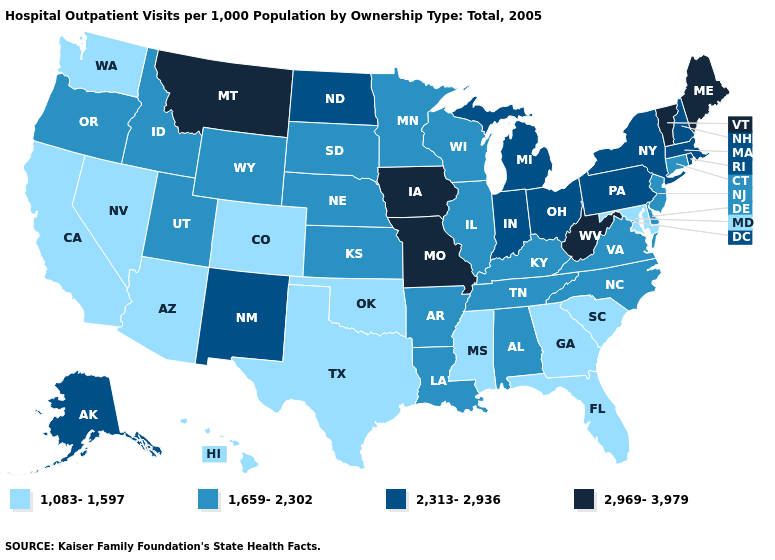What is the value of Nebraska?
Answer briefly. 1,659-2,302. Does Maine have the same value as Missouri?
Give a very brief answer. Yes. Name the states that have a value in the range 2,969-3,979?
Short answer required. Iowa, Maine, Missouri, Montana, Vermont, West Virginia. What is the value of Maine?
Short answer required. 2,969-3,979. Name the states that have a value in the range 1,083-1,597?
Short answer required. Arizona, California, Colorado, Florida, Georgia, Hawaii, Maryland, Mississippi, Nevada, Oklahoma, South Carolina, Texas, Washington. What is the value of New Jersey?
Write a very short answer. 1,659-2,302. What is the value of Kansas?
Concise answer only. 1,659-2,302. Among the states that border Michigan , which have the lowest value?
Give a very brief answer. Wisconsin. Which states have the highest value in the USA?
Give a very brief answer. Iowa, Maine, Missouri, Montana, Vermont, West Virginia. Name the states that have a value in the range 2,313-2,936?
Give a very brief answer. Alaska, Indiana, Massachusetts, Michigan, New Hampshire, New Mexico, New York, North Dakota, Ohio, Pennsylvania, Rhode Island. Name the states that have a value in the range 2,313-2,936?
Be succinct. Alaska, Indiana, Massachusetts, Michigan, New Hampshire, New Mexico, New York, North Dakota, Ohio, Pennsylvania, Rhode Island. Does North Dakota have the highest value in the USA?
Answer briefly. No. Name the states that have a value in the range 2,313-2,936?
Concise answer only. Alaska, Indiana, Massachusetts, Michigan, New Hampshire, New Mexico, New York, North Dakota, Ohio, Pennsylvania, Rhode Island. Name the states that have a value in the range 1,083-1,597?
Write a very short answer. Arizona, California, Colorado, Florida, Georgia, Hawaii, Maryland, Mississippi, Nevada, Oklahoma, South Carolina, Texas, Washington. What is the highest value in the USA?
Answer briefly. 2,969-3,979. 